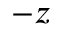Convert formula to latex. <formula><loc_0><loc_0><loc_500><loc_500>- z</formula> 